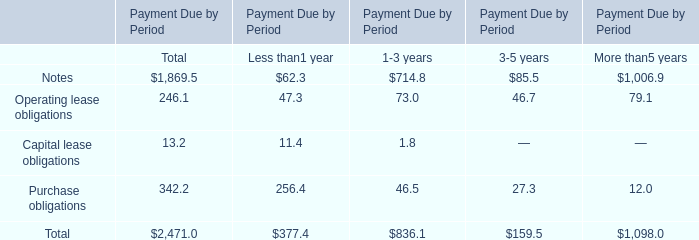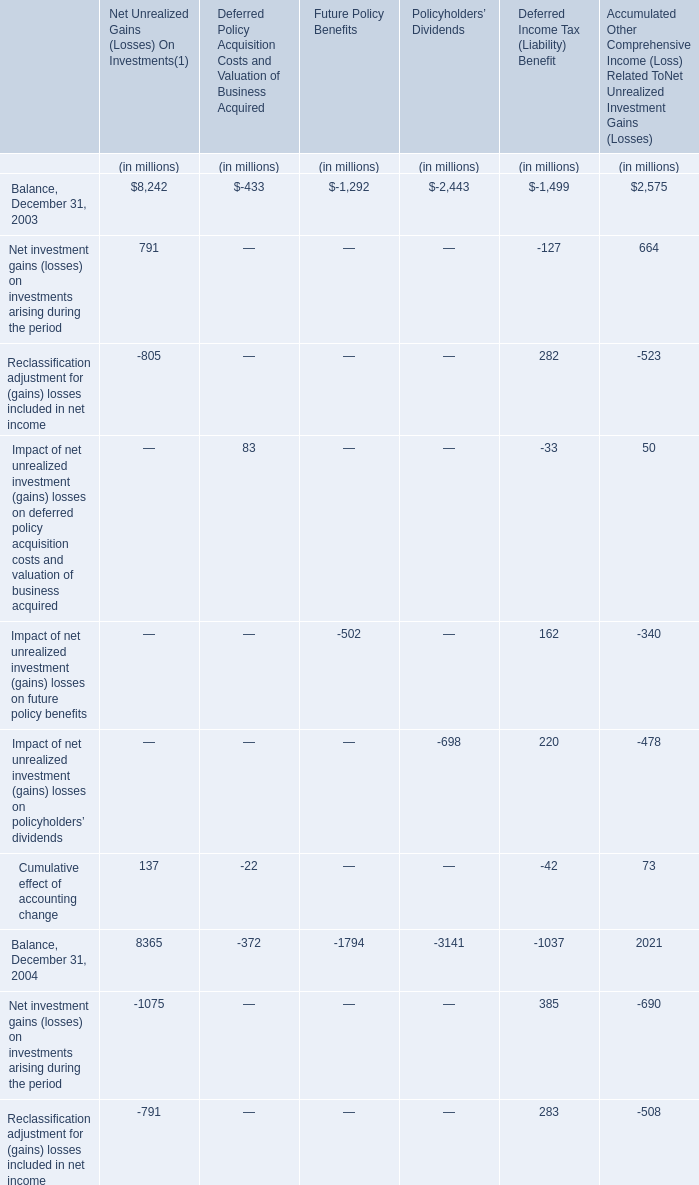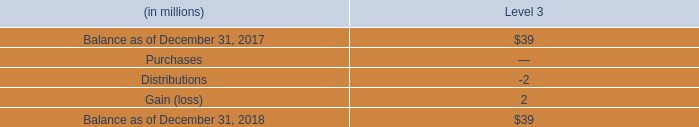What's the growth rate of Balance for Net Unrealized Gains On Investments on December 31 in 2005? 
Computations: ((6499 - 8365) / 8365)
Answer: -0.22307. 